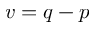<formula> <loc_0><loc_0><loc_500><loc_500>v = q - p</formula> 